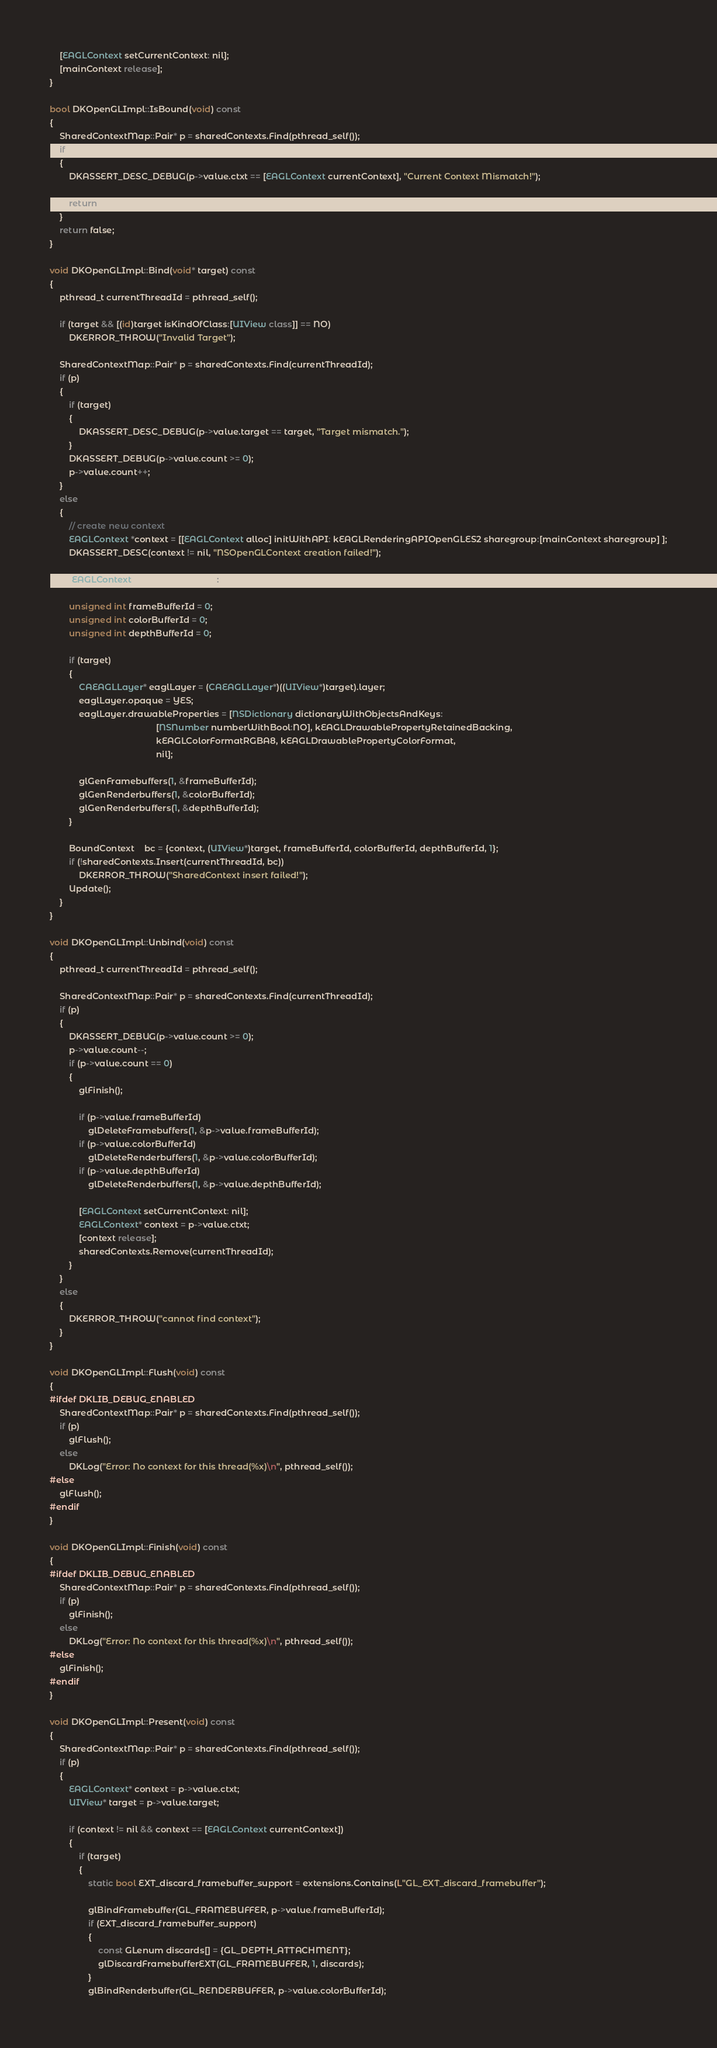Convert code to text. <code><loc_0><loc_0><loc_500><loc_500><_ObjectiveC_>
	[EAGLContext setCurrentContext: nil];
	[mainContext release];
}

bool DKOpenGLImpl::IsBound(void) const
{
	SharedContextMap::Pair* p = sharedContexts.Find(pthread_self());
	if (p)
	{
		DKASSERT_DESC_DEBUG(p->value.ctxt == [EAGLContext currentContext], "Current Context Mismatch!");
		
		return true;
	}
	return false;
}

void DKOpenGLImpl::Bind(void* target) const
{
	pthread_t currentThreadId = pthread_self();

	if (target && [(id)target isKindOfClass:[UIView class]] == NO)
		DKERROR_THROW("Invalid Target");
		
	SharedContextMap::Pair* p = sharedContexts.Find(currentThreadId);
	if (p)
	{
		if (target)
		{
			DKASSERT_DESC_DEBUG(p->value.target == target, "Target mismatch.");
		}
		DKASSERT_DEBUG(p->value.count >= 0);
		p->value.count++;
	}
	else
	{
		// create new context
		EAGLContext *context = [[EAGLContext alloc] initWithAPI: kEAGLRenderingAPIOpenGLES2 sharegroup:[mainContext sharegroup] ];
		DKASSERT_DESC(context != nil, "NSOpenGLContext creation failed!");

		[EAGLContext setCurrentContext:context];

		unsigned int frameBufferId = 0;
		unsigned int colorBufferId = 0;
		unsigned int depthBufferId = 0;
		
		if (target)
		{
			CAEAGLLayer* eaglLayer = (CAEAGLLayer*)((UIView*)target).layer;
			eaglLayer.opaque = YES;
			eaglLayer.drawableProperties = [NSDictionary dictionaryWithObjectsAndKeys:
											[NSNumber numberWithBool:NO], kEAGLDrawablePropertyRetainedBacking,
											kEAGLColorFormatRGBA8, kEAGLDrawablePropertyColorFormat,
											nil];
			
			glGenFramebuffers(1, &frameBufferId);
			glGenRenderbuffers(1, &colorBufferId);
			glGenRenderbuffers(1, &depthBufferId);
		}
		
		BoundContext	bc = {context, (UIView*)target, frameBufferId, colorBufferId, depthBufferId, 1};
		if (!sharedContexts.Insert(currentThreadId, bc))
			DKERROR_THROW("SharedContext insert failed!");
		Update();
	}
}

void DKOpenGLImpl::Unbind(void) const
{
	pthread_t currentThreadId = pthread_self();

	SharedContextMap::Pair* p = sharedContexts.Find(currentThreadId);
	if (p)
	{
		DKASSERT_DEBUG(p->value.count >= 0);
		p->value.count--;
		if (p->value.count == 0)
		{
			glFinish();
			
			if (p->value.frameBufferId)
				glDeleteFramebuffers(1, &p->value.frameBufferId);
			if (p->value.colorBufferId)
				glDeleteRenderbuffers(1, &p->value.colorBufferId);
			if (p->value.depthBufferId)
				glDeleteRenderbuffers(1, &p->value.depthBufferId);
			
			[EAGLContext setCurrentContext: nil];
			EAGLContext* context = p->value.ctxt;
			[context release];
			sharedContexts.Remove(currentThreadId);
		}
	}
	else
	{
		DKERROR_THROW("cannot find context");
	}
}

void DKOpenGLImpl::Flush(void) const
{
#ifdef DKLIB_DEBUG_ENABLED
	SharedContextMap::Pair* p = sharedContexts.Find(pthread_self());
	if (p)
		glFlush();
	else
		DKLog("Error: No context for this thread(%x)\n", pthread_self());
#else
	glFlush();
#endif
}

void DKOpenGLImpl::Finish(void) const
{
#ifdef DKLIB_DEBUG_ENABLED
	SharedContextMap::Pair* p = sharedContexts.Find(pthread_self());
	if (p)
		glFinish();
	else
		DKLog("Error: No context for this thread(%x)\n", pthread_self());
#else
	glFinish();
#endif
}

void DKOpenGLImpl::Present(void) const
{
	SharedContextMap::Pair* p = sharedContexts.Find(pthread_self());
	if (p)
	{
		EAGLContext* context = p->value.ctxt;
		UIView* target = p->value.target;
		
		if (context != nil && context == [EAGLContext currentContext])
		{
			if (target)
			{
				static bool EXT_discard_framebuffer_support = extensions.Contains(L"GL_EXT_discard_framebuffer");
				
				glBindFramebuffer(GL_FRAMEBUFFER, p->value.frameBufferId);
				if (EXT_discard_framebuffer_support)
				{
					const GLenum discards[] = {GL_DEPTH_ATTACHMENT};
					glDiscardFramebufferEXT(GL_FRAMEBUFFER, 1, discards);
				}
				glBindRenderbuffer(GL_RENDERBUFFER, p->value.colorBufferId);</code> 